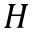<formula> <loc_0><loc_0><loc_500><loc_500>H</formula> 